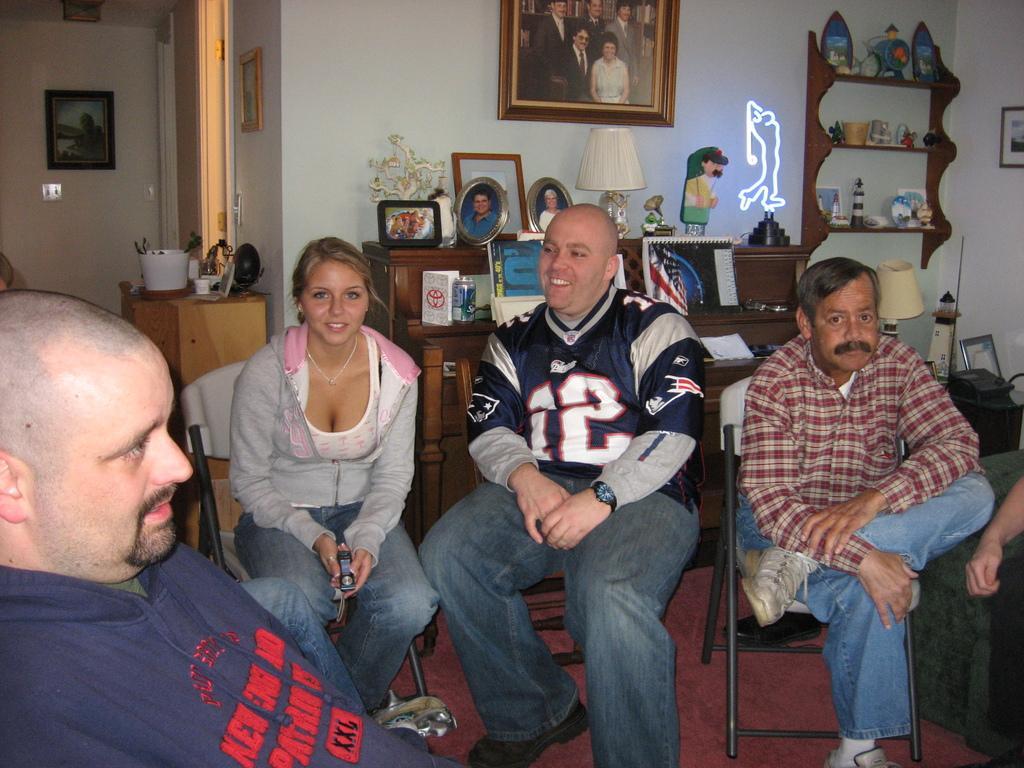Can you describe this image briefly? In this picture there are three people sitting on chairs in the center. Among them, there are two men and one woman. Towards the left, there is a man in blue jacket. To the wall there are two desks with frames, statue, lamp and show pieces. On the top left there is a door and a table. At the bottom right, there is a person sitting on the sofa. 